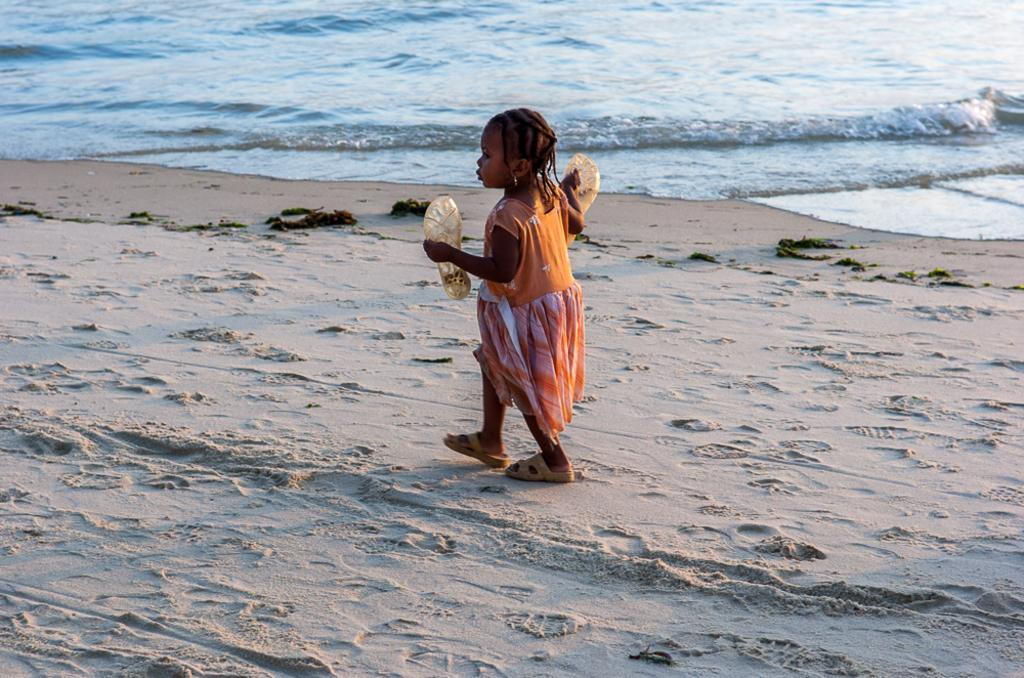Who is the main subject in the image? There is a girl in the image. What is the girl doing in the image? The girl is walking on a beach. What can be seen in the background of the image? There is water visible in the background of the image. What type of paint is being used by the girl on the railway in the image? There is no paint or railway present in the image; it features a girl walking on a beach. 